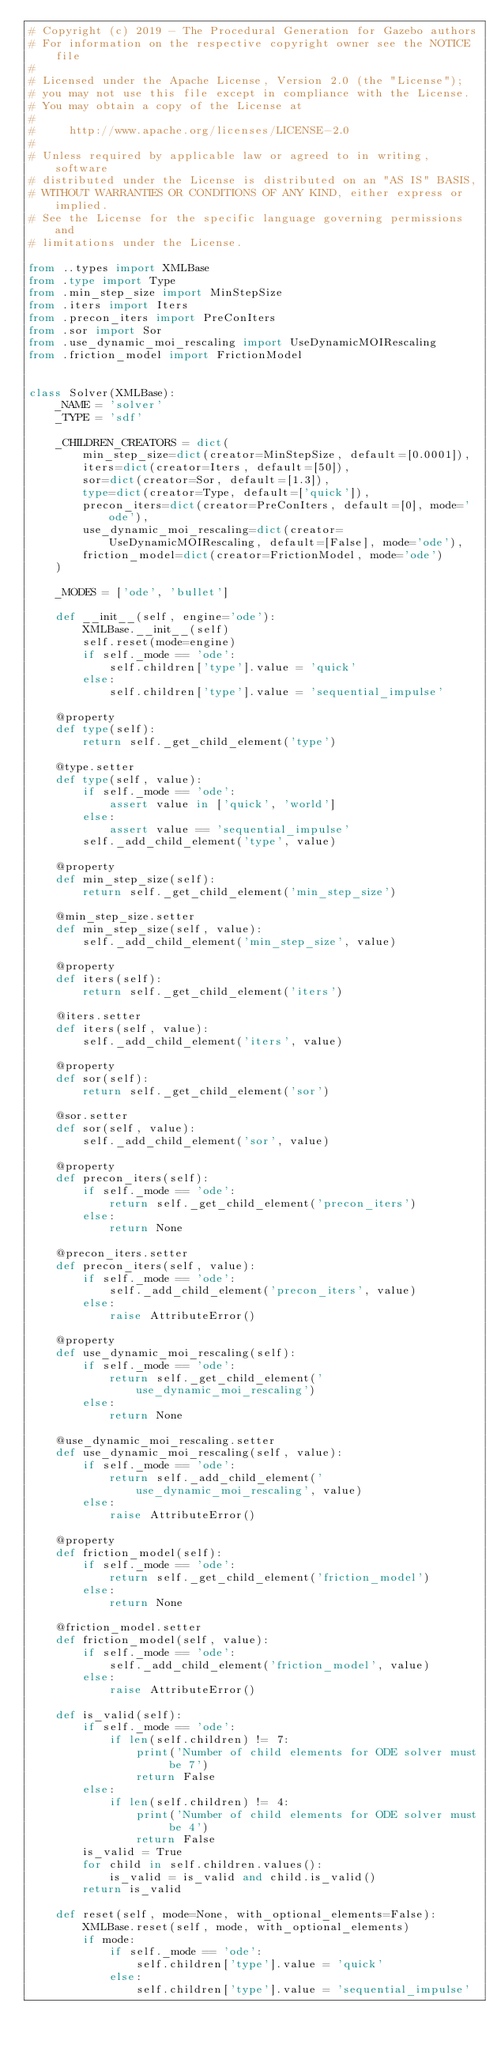<code> <loc_0><loc_0><loc_500><loc_500><_Python_># Copyright (c) 2019 - The Procedural Generation for Gazebo authors
# For information on the respective copyright owner see the NOTICE file
#
# Licensed under the Apache License, Version 2.0 (the "License");
# you may not use this file except in compliance with the License.
# You may obtain a copy of the License at
#
#     http://www.apache.org/licenses/LICENSE-2.0
#
# Unless required by applicable law or agreed to in writing, software
# distributed under the License is distributed on an "AS IS" BASIS,
# WITHOUT WARRANTIES OR CONDITIONS OF ANY KIND, either express or implied.
# See the License for the specific language governing permissions and
# limitations under the License.

from ..types import XMLBase
from .type import Type
from .min_step_size import MinStepSize
from .iters import Iters
from .precon_iters import PreConIters
from .sor import Sor
from .use_dynamic_moi_rescaling import UseDynamicMOIRescaling
from .friction_model import FrictionModel


class Solver(XMLBase):
    _NAME = 'solver'
    _TYPE = 'sdf'

    _CHILDREN_CREATORS = dict(
        min_step_size=dict(creator=MinStepSize, default=[0.0001]),
        iters=dict(creator=Iters, default=[50]),
        sor=dict(creator=Sor, default=[1.3]),
        type=dict(creator=Type, default=['quick']),
        precon_iters=dict(creator=PreConIters, default=[0], mode='ode'),
        use_dynamic_moi_rescaling=dict(creator=UseDynamicMOIRescaling, default=[False], mode='ode'),
        friction_model=dict(creator=FrictionModel, mode='ode')
    )

    _MODES = ['ode', 'bullet']

    def __init__(self, engine='ode'):
        XMLBase.__init__(self)
        self.reset(mode=engine)
        if self._mode == 'ode':
            self.children['type'].value = 'quick'
        else:
            self.children['type'].value = 'sequential_impulse'

    @property
    def type(self):
        return self._get_child_element('type')

    @type.setter
    def type(self, value):
        if self._mode == 'ode':
            assert value in ['quick', 'world']
        else:
            assert value == 'sequential_impulse'
        self._add_child_element('type', value)

    @property
    def min_step_size(self):
        return self._get_child_element('min_step_size')

    @min_step_size.setter
    def min_step_size(self, value):
        self._add_child_element('min_step_size', value)

    @property
    def iters(self):
        return self._get_child_element('iters')

    @iters.setter
    def iters(self, value):
        self._add_child_element('iters', value)

    @property
    def sor(self):
        return self._get_child_element('sor')

    @sor.setter
    def sor(self, value):
        self._add_child_element('sor', value)

    @property
    def precon_iters(self):
        if self._mode == 'ode':
            return self._get_child_element('precon_iters')
        else:
            return None

    @precon_iters.setter
    def precon_iters(self, value):
        if self._mode == 'ode':
            self._add_child_element('precon_iters', value)
        else:
            raise AttributeError()

    @property
    def use_dynamic_moi_rescaling(self):
        if self._mode == 'ode':
            return self._get_child_element('use_dynamic_moi_rescaling')
        else:
            return None

    @use_dynamic_moi_rescaling.setter
    def use_dynamic_moi_rescaling(self, value):
        if self._mode == 'ode':
            return self._add_child_element('use_dynamic_moi_rescaling', value)
        else:
            raise AttributeError()

    @property
    def friction_model(self):
        if self._mode == 'ode':
            return self._get_child_element('friction_model')
        else:
            return None

    @friction_model.setter
    def friction_model(self, value):
        if self._mode == 'ode':
            self._add_child_element('friction_model', value)
        else:
            raise AttributeError()

    def is_valid(self):
        if self._mode == 'ode':
            if len(self.children) != 7:
                print('Number of child elements for ODE solver must be 7')
                return False
        else:
            if len(self.children) != 4:
                print('Number of child elements for ODE solver must be 4')
                return False
        is_valid = True
        for child in self.children.values():
            is_valid = is_valid and child.is_valid()
        return is_valid

    def reset(self, mode=None, with_optional_elements=False):
        XMLBase.reset(self, mode, with_optional_elements)
        if mode:
            if self._mode == 'ode':
                self.children['type'].value = 'quick'
            else:
                self.children['type'].value = 'sequential_impulse'</code> 